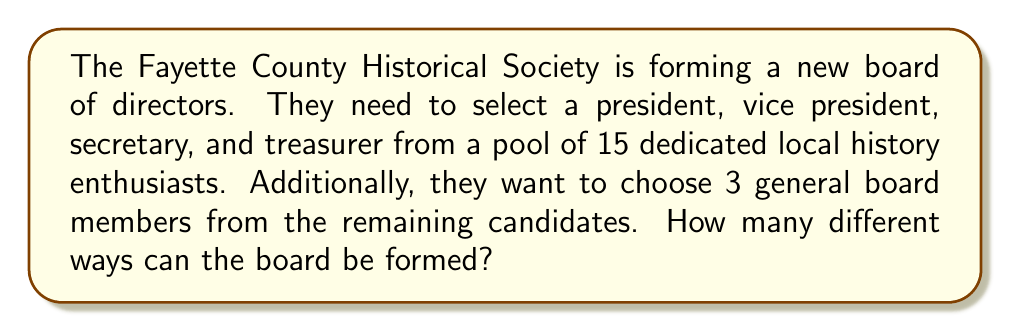What is the answer to this math problem? Let's approach this step-by-step:

1) First, we need to select the four officer positions (president, vice president, secretary, and treasurer) from the 15 candidates. This is a permutation problem because the order matters for these positions.

   Number of ways to select officers = $P(15,4) = \frac{15!}{(15-4)!} = \frac{15!}{11!} = 15 \times 14 \times 13 \times 12 = 32,760$

2) After selecting the officers, we have 11 candidates left (15 - 4 = 11).

3) From these 11, we need to select 3 general board members. The order doesn't matter for these positions, so this is a combination problem.

   Number of ways to select general board members = $C(11,3) = \binom{11}{3} = \frac{11!}{3!(11-3)!} = \frac{11!}{3!8!} = 165$

4) By the Multiplication Principle, the total number of ways to form the board is the product of the number of ways to select the officers and the number of ways to select the general board members.

   Total number of ways = $32,760 \times 165 = 5,405,400$

Therefore, there are 5,405,400 different ways to form the board.
Answer: $5,405,400$ 